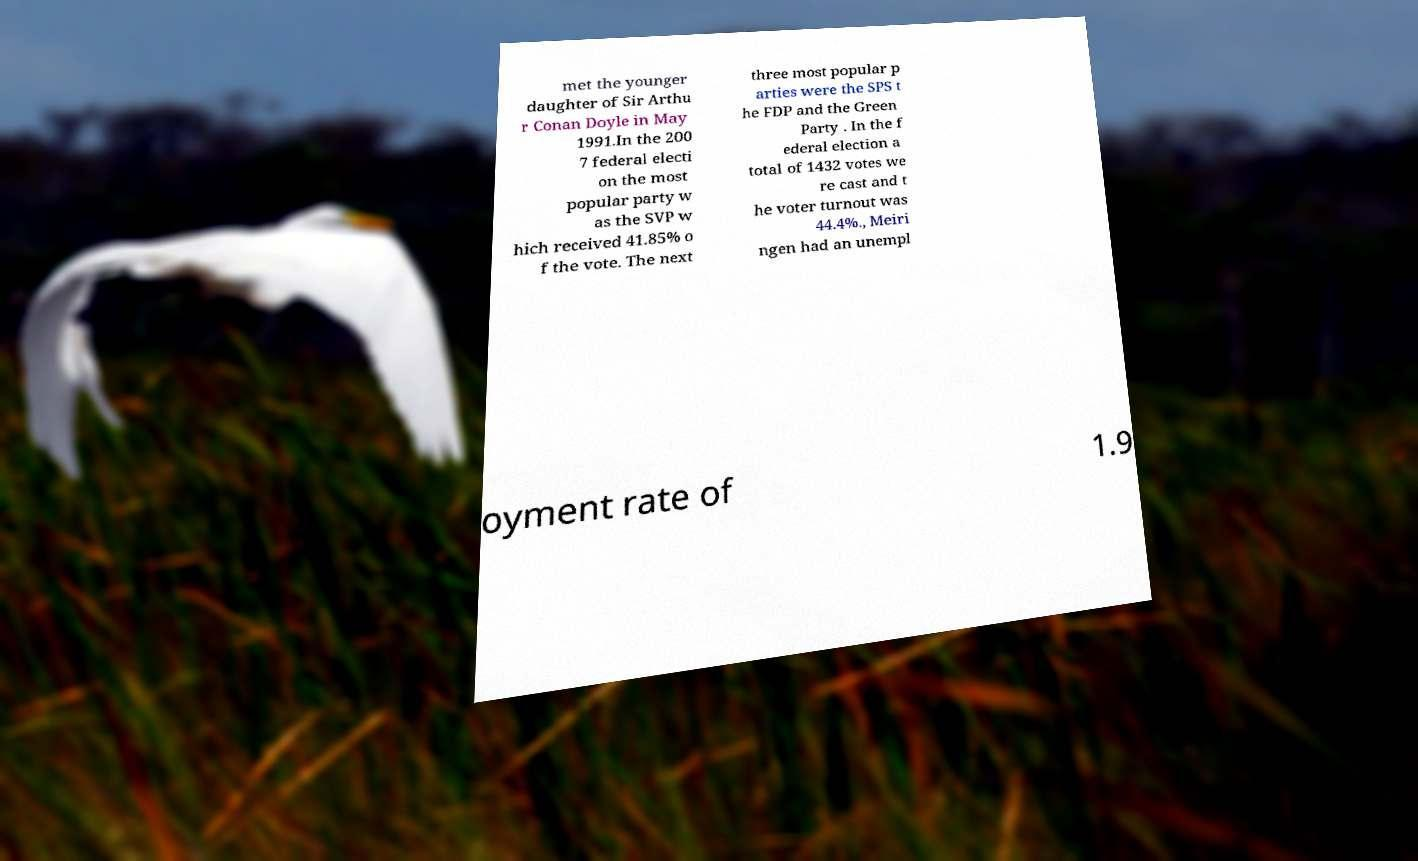Please read and relay the text visible in this image. What does it say? met the younger daughter of Sir Arthu r Conan Doyle in May 1991.In the 200 7 federal electi on the most popular party w as the SVP w hich received 41.85% o f the vote. The next three most popular p arties were the SPS t he FDP and the Green Party . In the f ederal election a total of 1432 votes we re cast and t he voter turnout was 44.4%., Meiri ngen had an unempl oyment rate of 1.9 